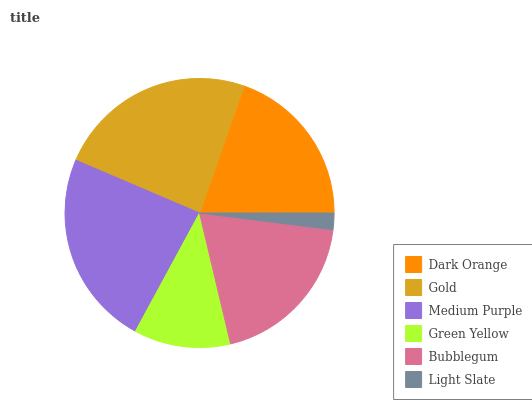Is Light Slate the minimum?
Answer yes or no. Yes. Is Gold the maximum?
Answer yes or no. Yes. Is Medium Purple the minimum?
Answer yes or no. No. Is Medium Purple the maximum?
Answer yes or no. No. Is Gold greater than Medium Purple?
Answer yes or no. Yes. Is Medium Purple less than Gold?
Answer yes or no. Yes. Is Medium Purple greater than Gold?
Answer yes or no. No. Is Gold less than Medium Purple?
Answer yes or no. No. Is Dark Orange the high median?
Answer yes or no. Yes. Is Bubblegum the low median?
Answer yes or no. Yes. Is Gold the high median?
Answer yes or no. No. Is Medium Purple the low median?
Answer yes or no. No. 